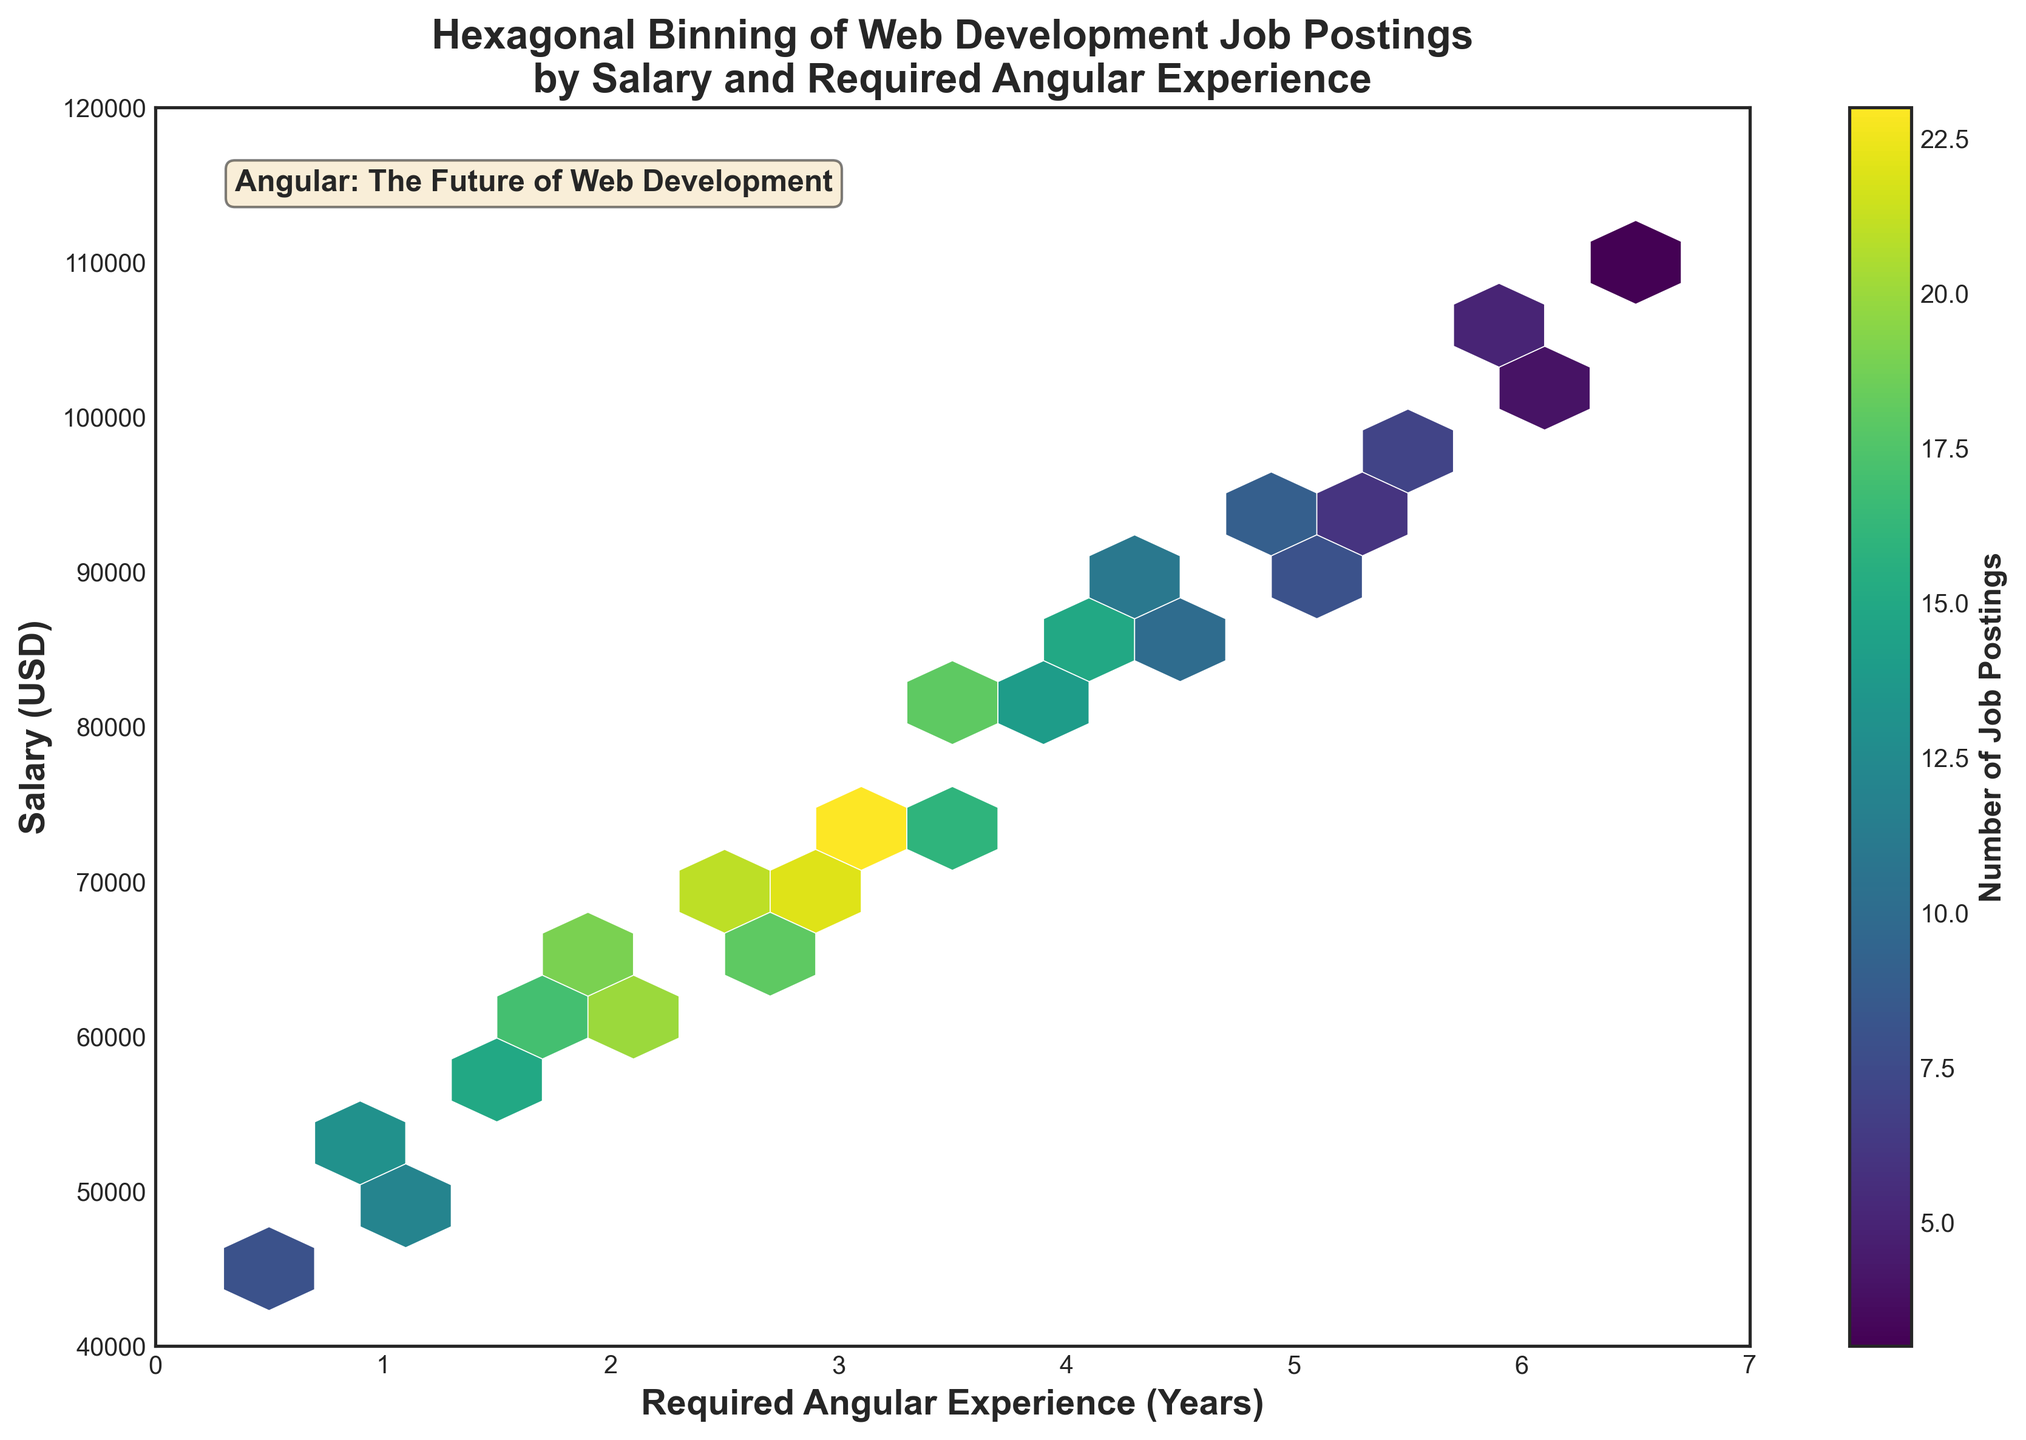What's the title of the plot? The title is displayed at the top of the plot. It states: "Hexagonal Binning of Web Development Job Postings by Salary and Required Angular Experience."
Answer: Hexagonal Binning of Web Development Job Postings by Salary and Required Angular Experience What does the color bar represent? The color bar shows the scale of colors indicating the number of job postings. The label on the color bar says, "Number of Job Postings."
Answer: Number of Job Postings What's the range of the x-axis? The x-axis is labeled "Required Angular Experience (Years)" and ranges from 0 to 7 years. You can see this by looking at the labels at the bottom of the plot.
Answer: 0 to 7 Which area on the hexbin plot has the highest concentration of job postings? Look for the darkest area in the plot, which is around 75000-80000 USD salary and 3-3.5 years of Angular experience. The color indicates the highest concentration.
Answer: Around 75000-80000 USD salary and 3-3.5 years of Angular experience How many job postings are there for 5 years of Angular experience with a salary around 90000 USD? Look at the hexbin around 5 years on the x-axis and 90000 USD on the y-axis. The color of the hexbin indicates the number from the color bar. The dark green hexbin suggests there are 9 job postings.
Answer: 9 What is the correlation between Angular experience and salary depicted in the plot? The plot shows a positive correlation. As Angular experience increases from left to right, the salary also tends to increase from bottom to top. This indicates that more Angular experience generally leads to higher salaries.
Answer: Positive correlation What is the most common range of salaries for job postings requiring less than 1 year of Angular experience? Look at the hexbin densities on the left side of the x-axis (less than 1 year). The highest densities occur around the salary range of 45000-55000 USD.
Answer: 45000-55000 USD Which salary range has postings requiring the lowest Angular experience? Check the leftmost side of the plot on the x-axis (0.5 to 1 year). These are associated with the lowest salary range, around 45000-50000 USD.
Answer: 45000-50000 USD Are there more job postings for 4 years of Angular experience or 6 years? Compare the densities of the hexbin plots for 4 years and 6 years of Angular experience. Both sides of the color bar suggest more postings for 4 years. The color density is higher at 4 years than at 6 years.
Answer: 4 years What can be inferred about web development job postings based on the text in the plot? The text box in the plot states, "Angular: The Future of Web Development," suggesting a strong belief in Angular's importance for web development careers.
Answer: Angular is considered the future of web development 